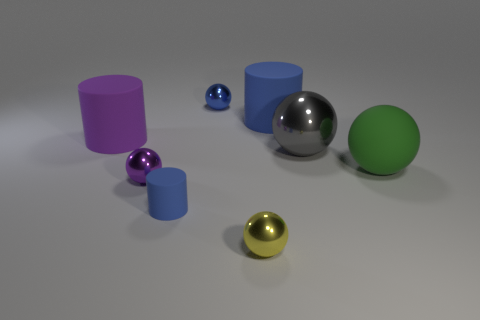Subtract all purple balls. How many balls are left? 4 Subtract all yellow spheres. How many spheres are left? 4 Subtract 3 balls. How many balls are left? 2 Add 1 purple rubber things. How many objects exist? 9 Subtract all red spheres. Subtract all blue cylinders. How many spheres are left? 5 Subtract all cylinders. How many objects are left? 5 Subtract all blue matte spheres. Subtract all blue matte cylinders. How many objects are left? 6 Add 6 tiny blue rubber cylinders. How many tiny blue rubber cylinders are left? 7 Add 3 blue cylinders. How many blue cylinders exist? 5 Subtract 0 yellow cylinders. How many objects are left? 8 